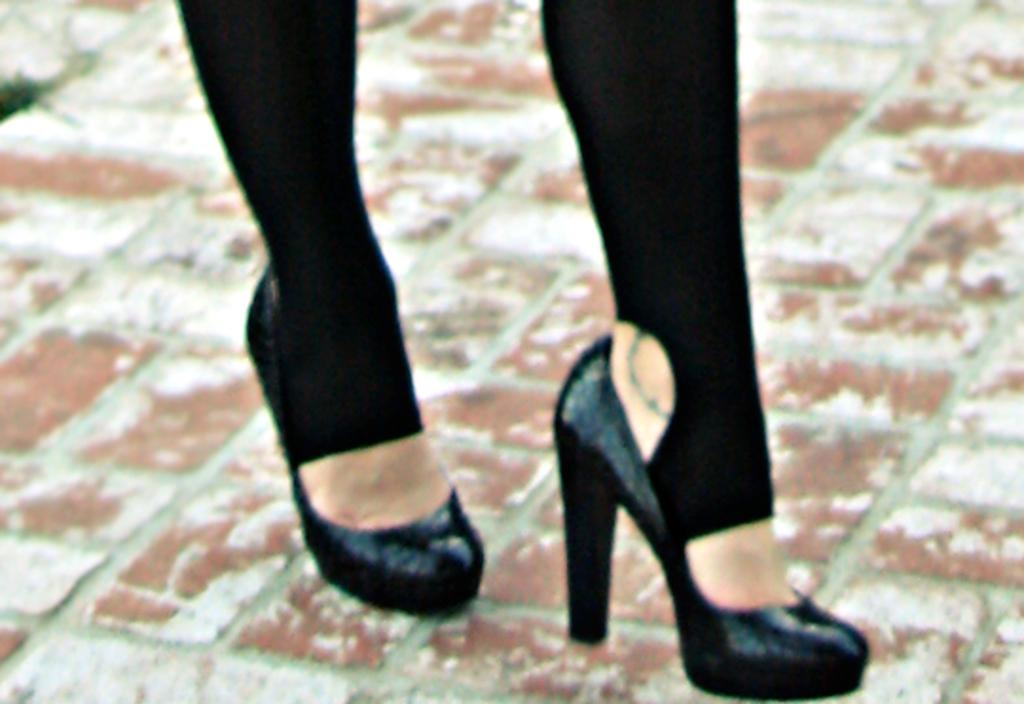What can be seen at the bottom of the image? There are legs visible in the image. What type of footwear is the person wearing? The person is wearing black shoes. Where are the legs located in the image? The legs are on the floor. What type of knife is being used to promote peace in the image? There is no knife present in the image, and the concept of promoting peace is not mentioned. 